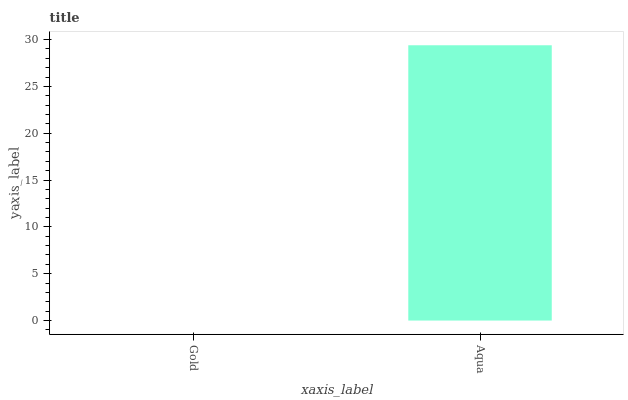Is Gold the minimum?
Answer yes or no. Yes. Is Aqua the maximum?
Answer yes or no. Yes. Is Aqua the minimum?
Answer yes or no. No. Is Aqua greater than Gold?
Answer yes or no. Yes. Is Gold less than Aqua?
Answer yes or no. Yes. Is Gold greater than Aqua?
Answer yes or no. No. Is Aqua less than Gold?
Answer yes or no. No. Is Aqua the high median?
Answer yes or no. Yes. Is Gold the low median?
Answer yes or no. Yes. Is Gold the high median?
Answer yes or no. No. Is Aqua the low median?
Answer yes or no. No. 